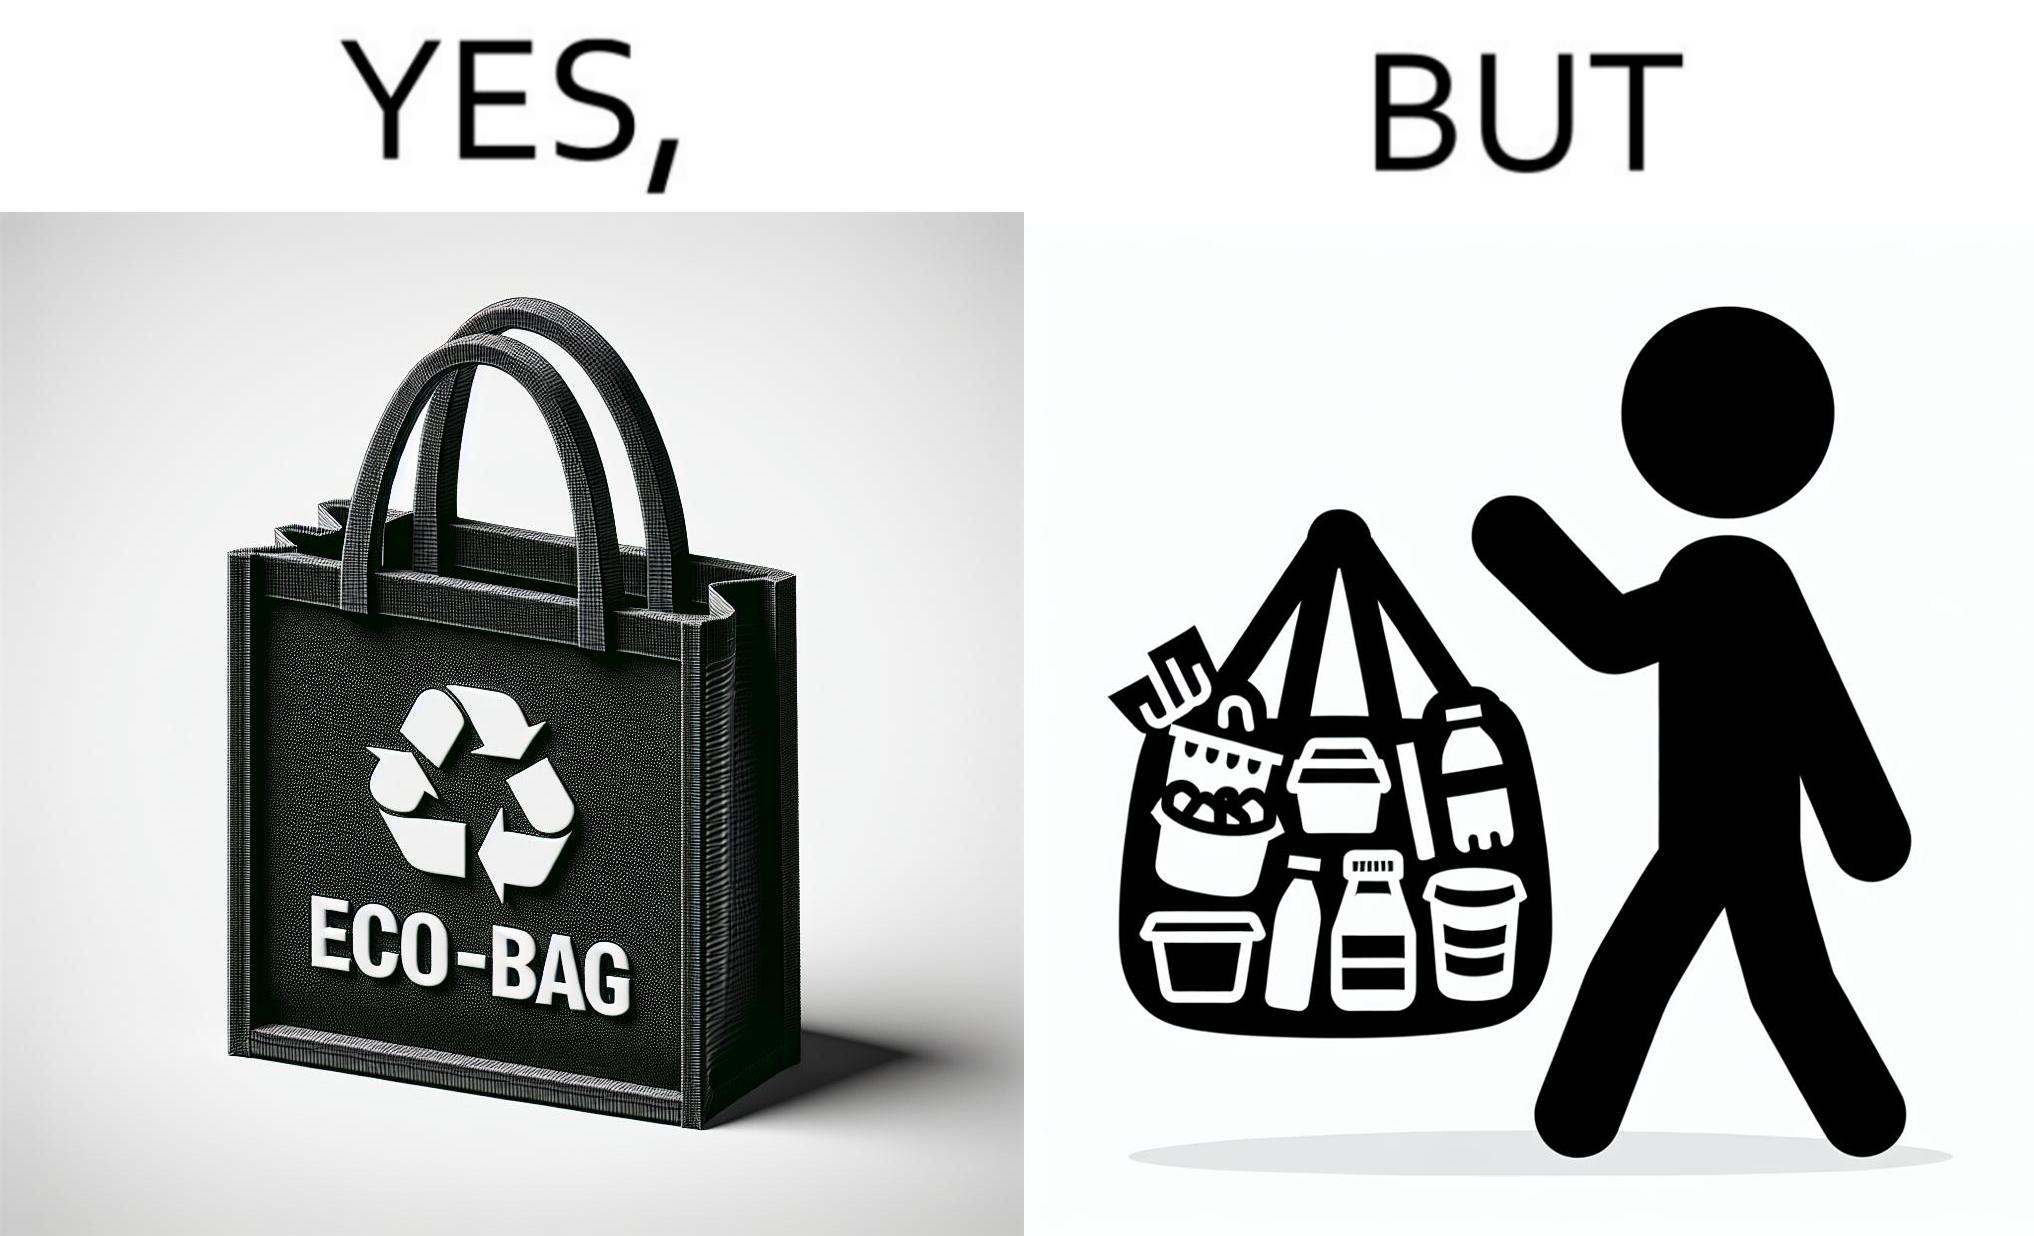What is shown in this image? The image is ironic, because people nowadays use eco-bag thinking them as safe for the environment but in turn use products which are harmful for the environment or are packaged in some non-biodegradable material 